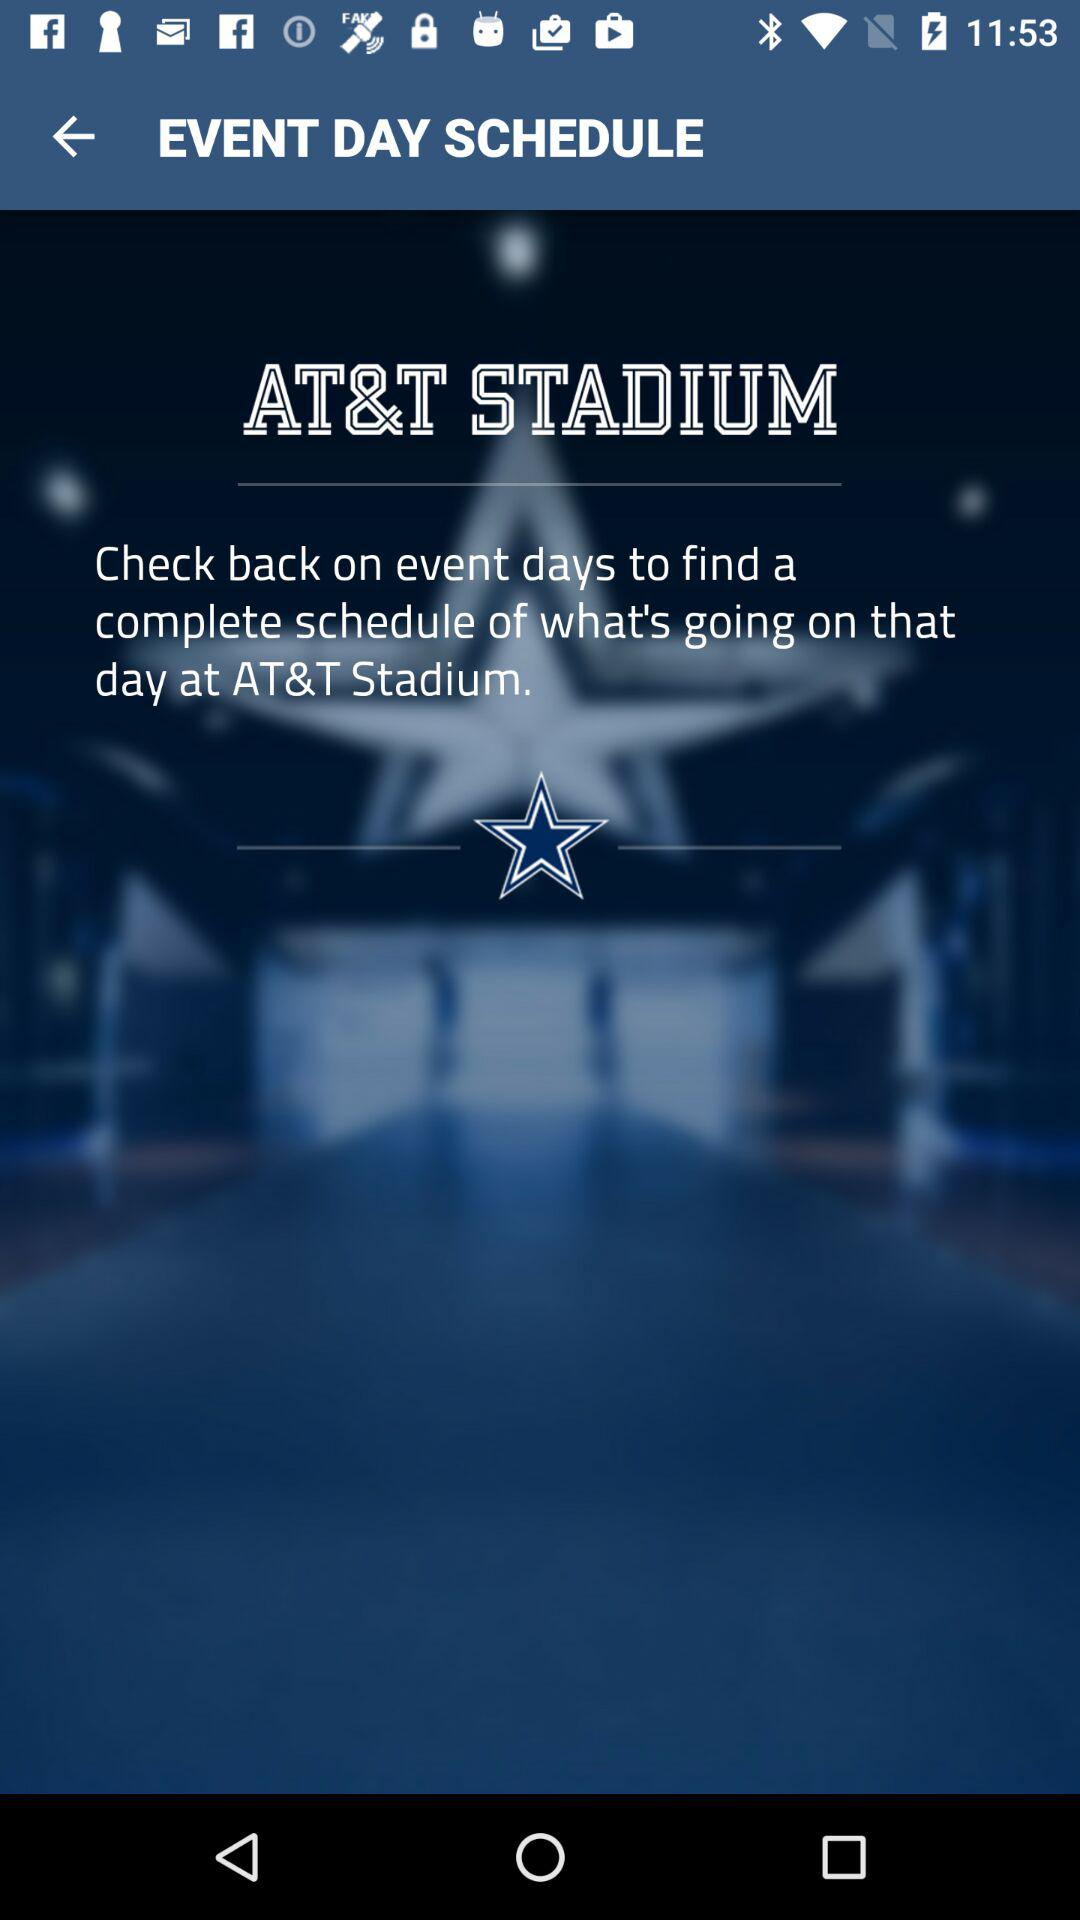Who can we phone for information about the stadium schedule?
When the provided information is insufficient, respond with <no answer>. <no answer> 